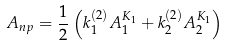Convert formula to latex. <formula><loc_0><loc_0><loc_500><loc_500>A _ { n p } = \frac { 1 } { 2 } \left ( k _ { 1 } ^ { ( 2 ) } A _ { 1 } ^ { K _ { 1 } } + k _ { 2 } ^ { ( 2 ) } A _ { 2 } ^ { K _ { 1 } } \right ) \,</formula> 